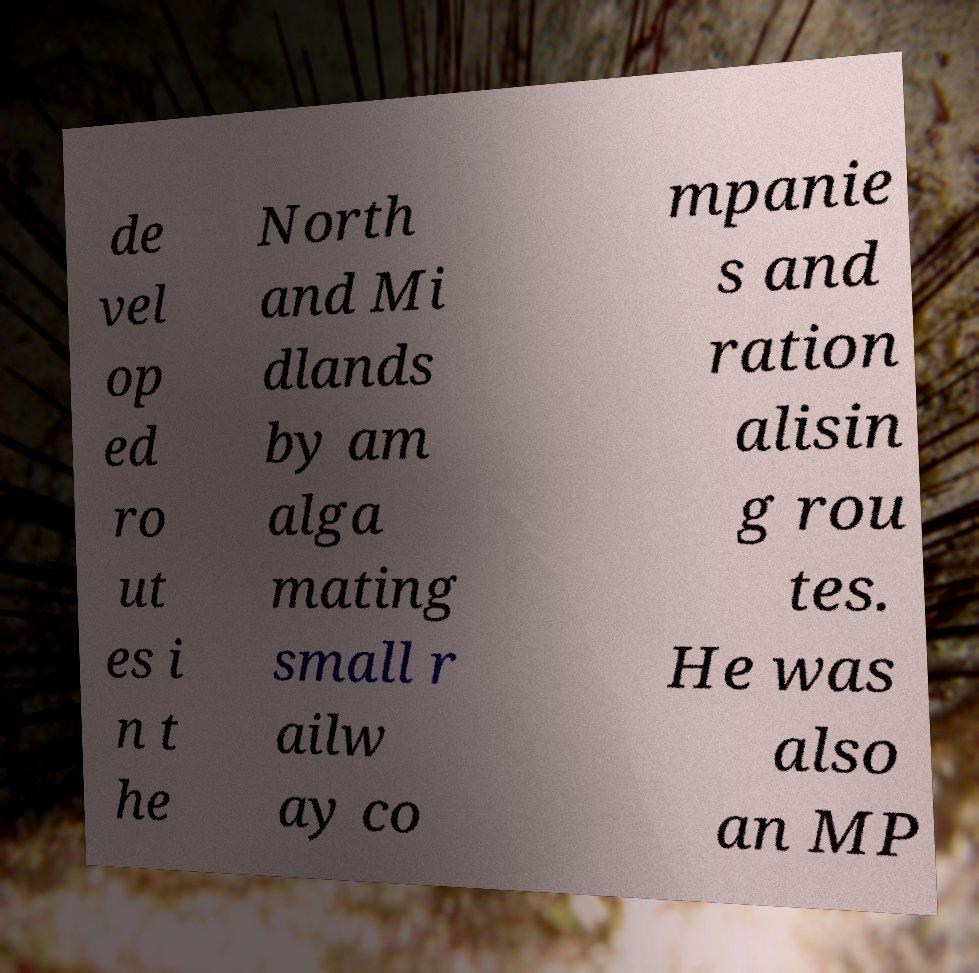What messages or text are displayed in this image? I need them in a readable, typed format. de vel op ed ro ut es i n t he North and Mi dlands by am alga mating small r ailw ay co mpanie s and ration alisin g rou tes. He was also an MP 